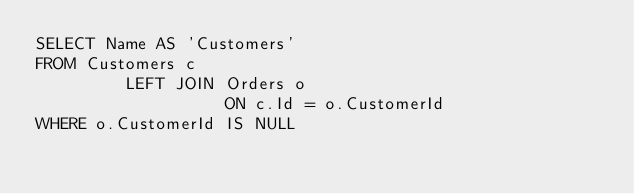Convert code to text. <code><loc_0><loc_0><loc_500><loc_500><_SQL_>SELECT Name AS 'Customers'
FROM Customers c
         LEFT JOIN Orders o
                   ON c.Id = o.CustomerId
WHERE o.CustomerId IS NULL</code> 